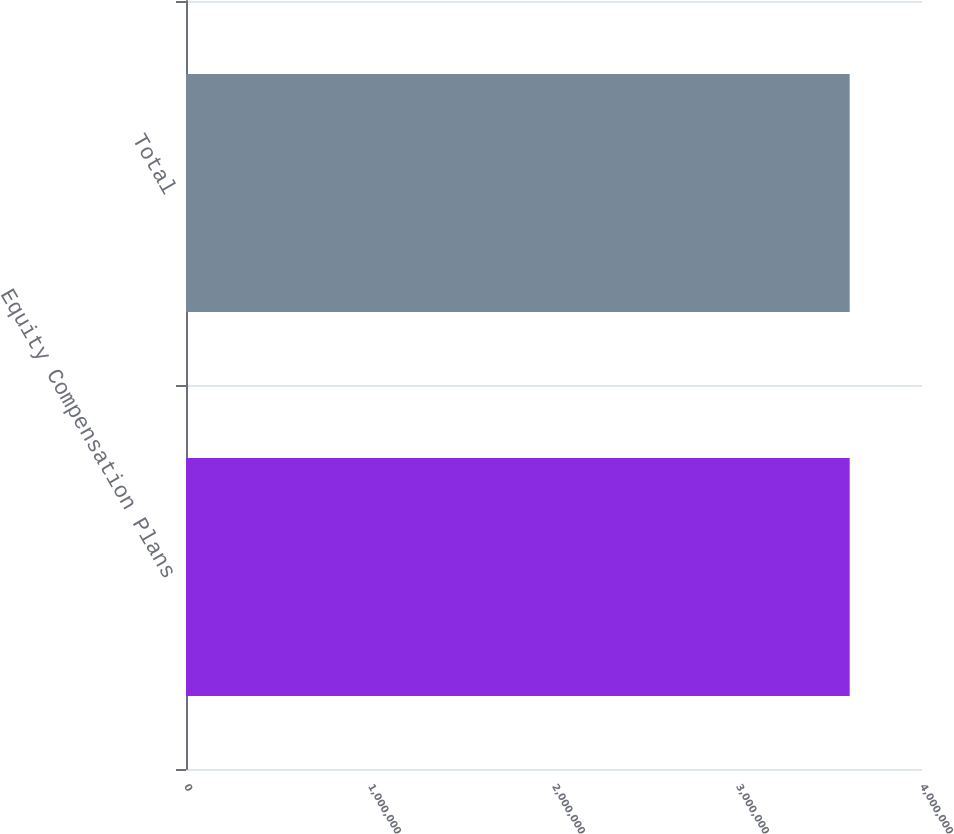Convert chart. <chart><loc_0><loc_0><loc_500><loc_500><bar_chart><fcel>Equity Compensation Plans<fcel>Total<nl><fcel>3.607e+06<fcel>3.607e+06<nl></chart> 